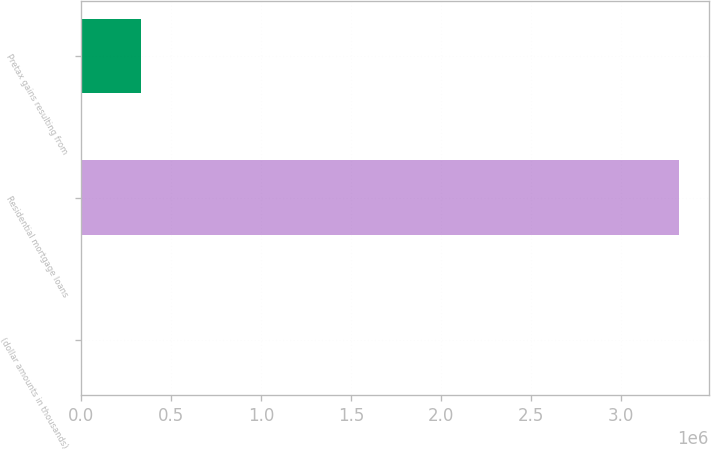Convert chart to OTSL. <chart><loc_0><loc_0><loc_500><loc_500><bar_chart><fcel>(dollar amounts in thousands)<fcel>Residential mortgage loans<fcel>Pretax gains resulting from<nl><fcel>2015<fcel>3.32272e+06<fcel>334086<nl></chart> 